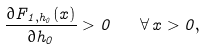Convert formula to latex. <formula><loc_0><loc_0><loc_500><loc_500>\frac { \partial F _ { 1 , h _ { 0 } } ( x ) } { \partial h _ { 0 } } > 0 \quad \forall \, x > 0 ,</formula> 